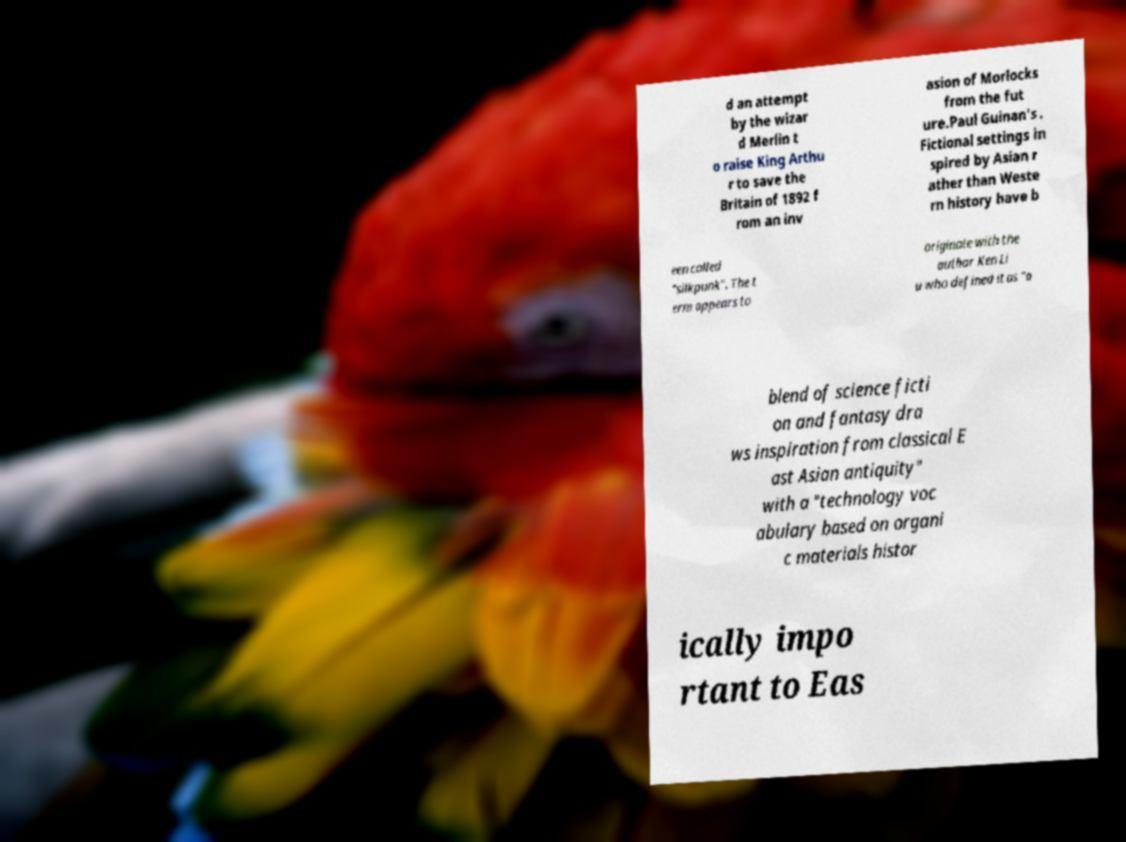Can you accurately transcribe the text from the provided image for me? d an attempt by the wizar d Merlin t o raise King Arthu r to save the Britain of 1892 f rom an inv asion of Morlocks from the fut ure.Paul Guinan's . Fictional settings in spired by Asian r ather than Weste rn history have b een called "silkpunk". The t erm appears to originate with the author Ken Li u who defined it as "a blend of science ficti on and fantasy dra ws inspiration from classical E ast Asian antiquity" with a "technology voc abulary based on organi c materials histor ically impo rtant to Eas 